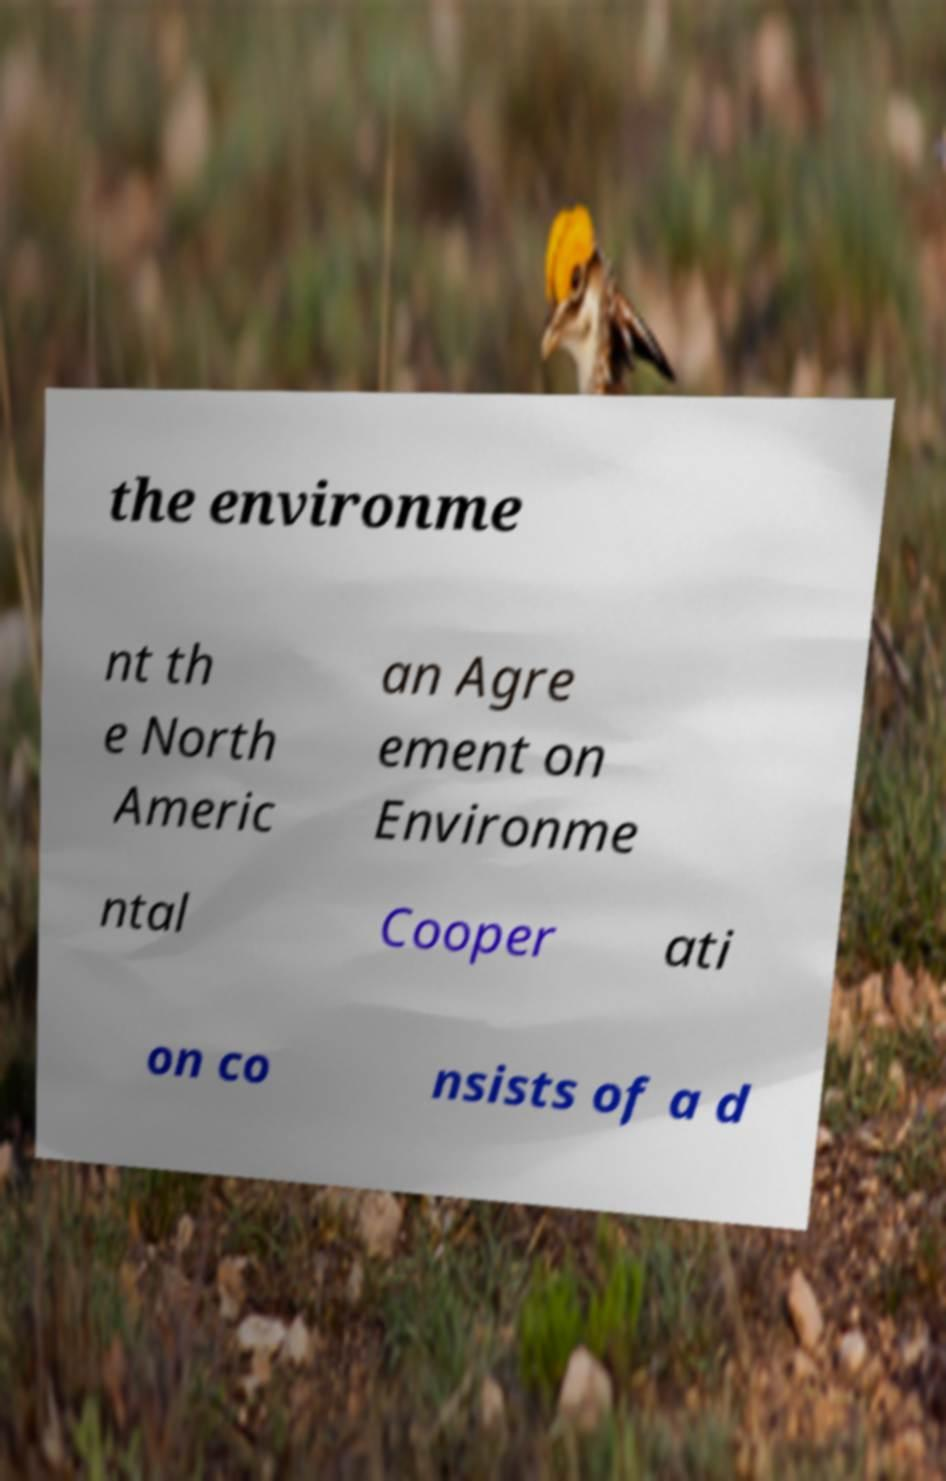Please identify and transcribe the text found in this image. the environme nt th e North Americ an Agre ement on Environme ntal Cooper ati on co nsists of a d 